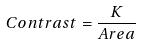<formula> <loc_0><loc_0><loc_500><loc_500>C o n t r a s t = \frac { K } { A r e a }</formula> 